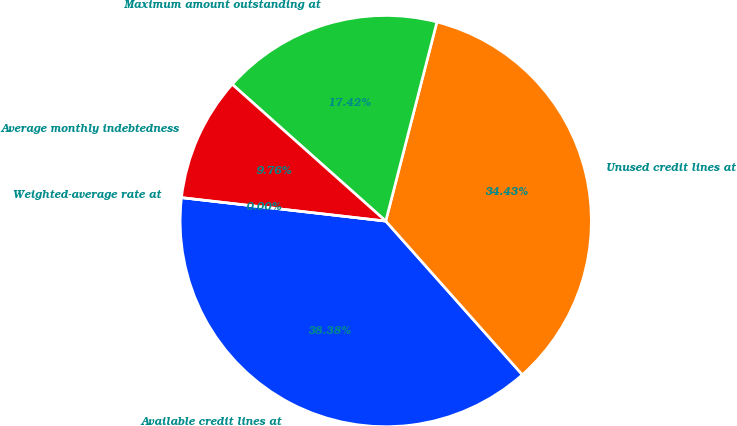Convert chart. <chart><loc_0><loc_0><loc_500><loc_500><pie_chart><fcel>Available credit lines at<fcel>Unused credit lines at<fcel>Maximum amount outstanding at<fcel>Average monthly indebtedness<fcel>Weighted-average rate at<nl><fcel>38.38%<fcel>34.43%<fcel>17.42%<fcel>9.76%<fcel>0.0%<nl></chart> 